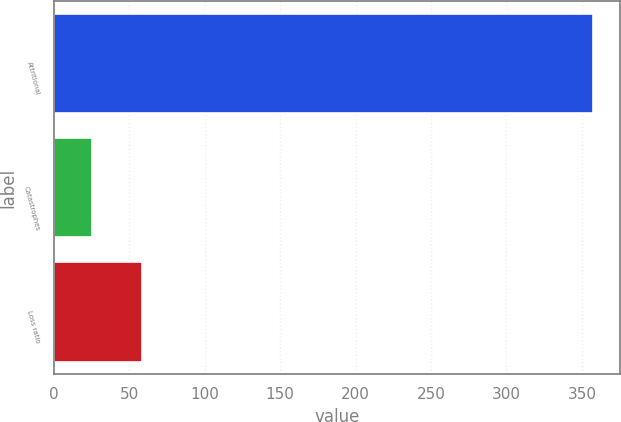<chart> <loc_0><loc_0><loc_500><loc_500><bar_chart><fcel>Attritional<fcel>Catastrophes<fcel>Loss ratio<nl><fcel>357.5<fcel>25.3<fcel>58.52<nl></chart> 